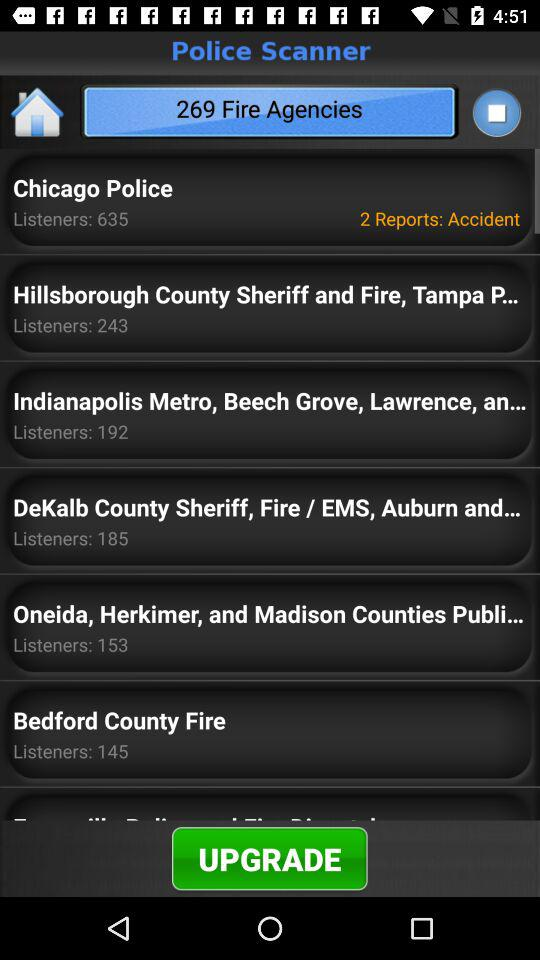How many fire agencies are there? There are 269 fire agencies. 